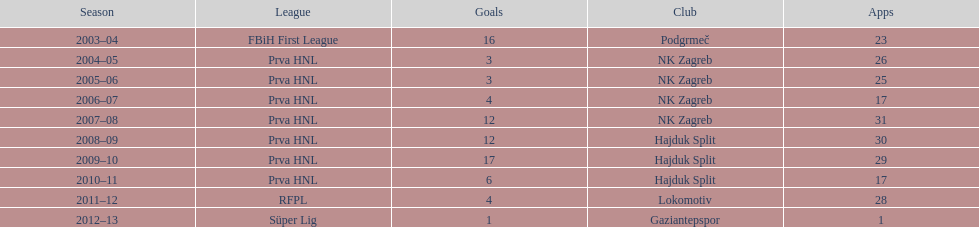Did ibricic score more or less goals in his 3 seasons with hajduk split when compared to his 4 seasons with nk zagreb? More. 